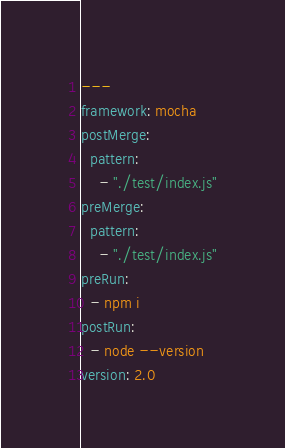Convert code to text. <code><loc_0><loc_0><loc_500><loc_500><_YAML_>---
framework: mocha
postMerge:
  pattern:
    - "./test/index.js"
preMerge:
  pattern:
    - "./test/index.js"
preRun:
  - npm i
postRun:
  - node --version
version: 2.0
</code> 